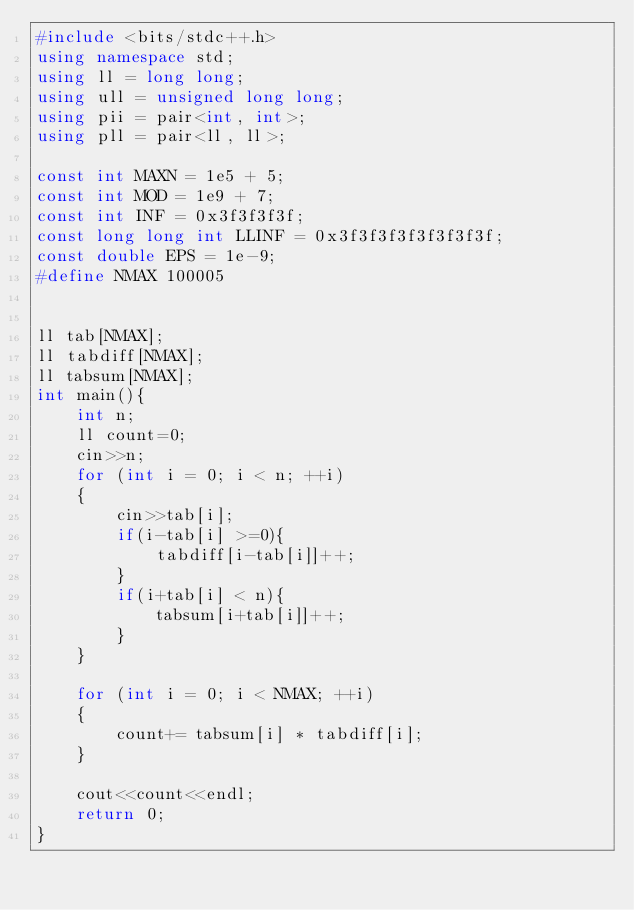<code> <loc_0><loc_0><loc_500><loc_500><_C++_>#include <bits/stdc++.h>
using namespace std;
using ll = long long;
using ull = unsigned long long;
using pii = pair<int, int>;
using pll = pair<ll, ll>;

const int MAXN = 1e5 + 5;
const int MOD = 1e9 + 7;
const int INF = 0x3f3f3f3f;
const long long int LLINF = 0x3f3f3f3f3f3f3f3f;
const double EPS = 1e-9;
#define NMAX 100005


ll tab[NMAX];
ll tabdiff[NMAX];
ll tabsum[NMAX];
int main(){
    int n;
    ll count=0;
    cin>>n;
    for (int i = 0; i < n; ++i)
    {
        cin>>tab[i];
        if(i-tab[i] >=0){
            tabdiff[i-tab[i]]++;
        }
        if(i+tab[i] < n){
            tabsum[i+tab[i]]++;
        }
    }

    for (int i = 0; i < NMAX; ++i)
    {
        count+= tabsum[i] * tabdiff[i];
    }

    cout<<count<<endl;
    return 0;
}
</code> 